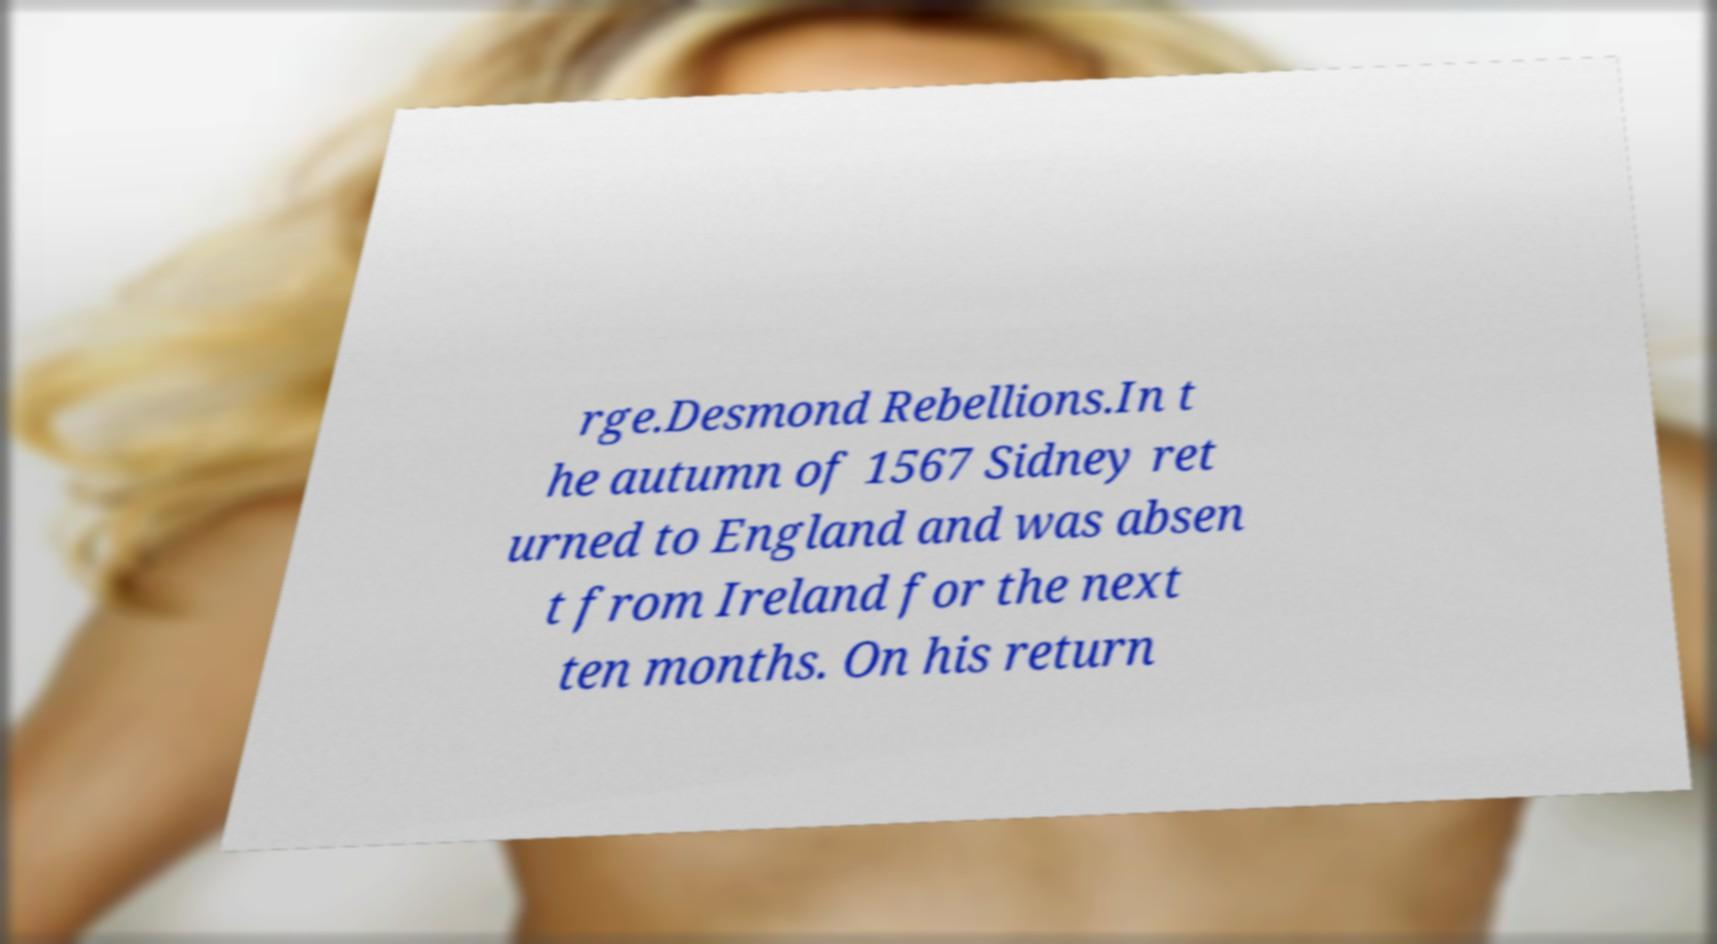Can you read and provide the text displayed in the image?This photo seems to have some interesting text. Can you extract and type it out for me? rge.Desmond Rebellions.In t he autumn of 1567 Sidney ret urned to England and was absen t from Ireland for the next ten months. On his return 